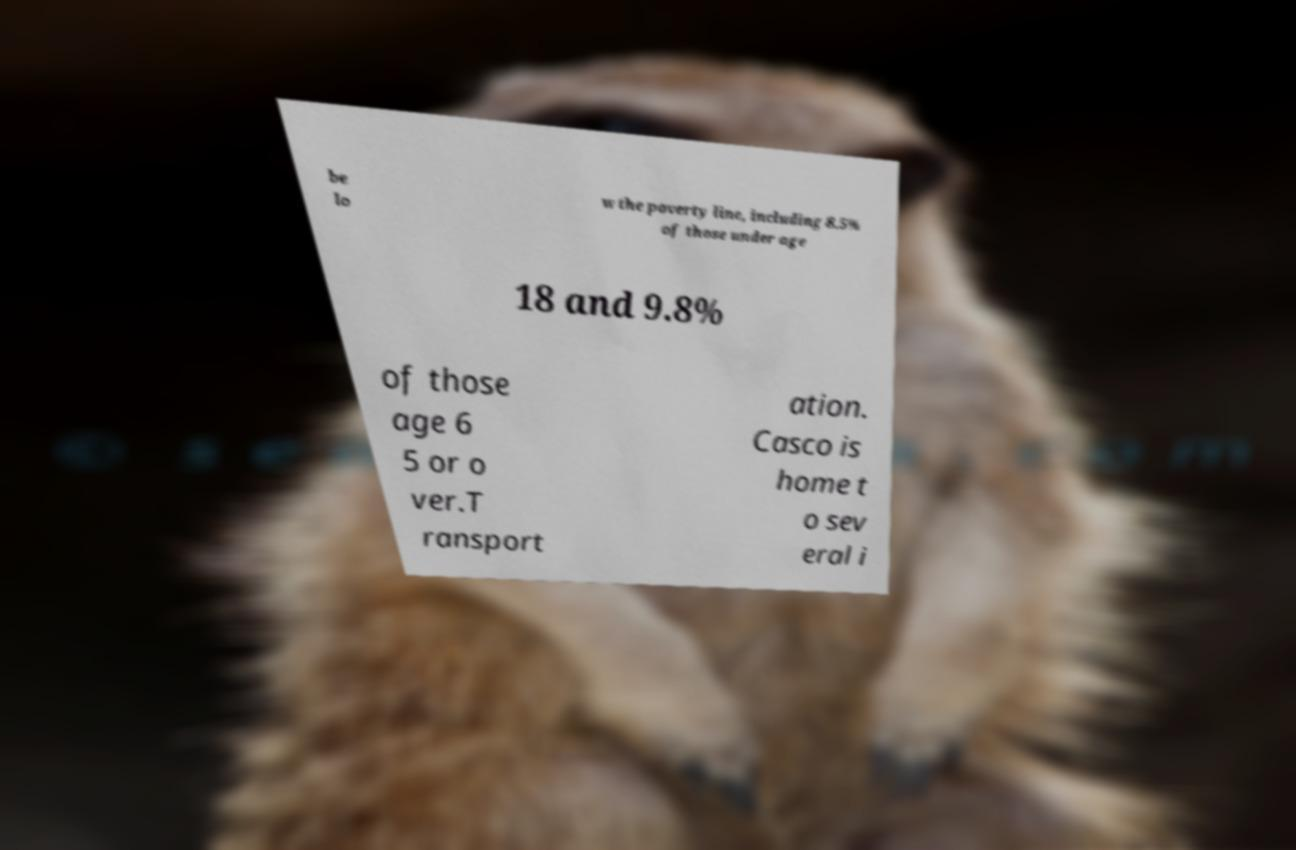There's text embedded in this image that I need extracted. Can you transcribe it verbatim? be lo w the poverty line, including 8.5% of those under age 18 and 9.8% of those age 6 5 or o ver.T ransport ation. Casco is home t o sev eral i 